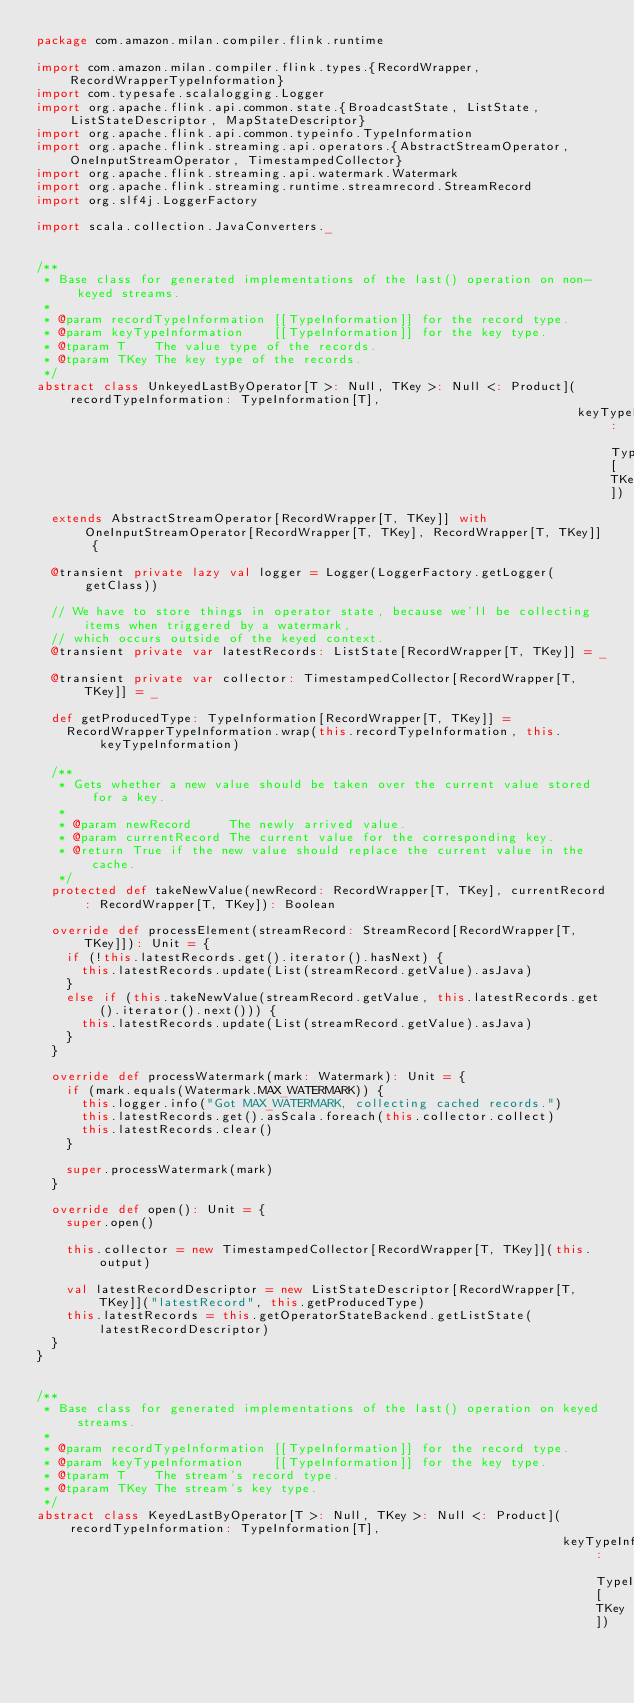<code> <loc_0><loc_0><loc_500><loc_500><_Scala_>package com.amazon.milan.compiler.flink.runtime

import com.amazon.milan.compiler.flink.types.{RecordWrapper, RecordWrapperTypeInformation}
import com.typesafe.scalalogging.Logger
import org.apache.flink.api.common.state.{BroadcastState, ListState, ListStateDescriptor, MapStateDescriptor}
import org.apache.flink.api.common.typeinfo.TypeInformation
import org.apache.flink.streaming.api.operators.{AbstractStreamOperator, OneInputStreamOperator, TimestampedCollector}
import org.apache.flink.streaming.api.watermark.Watermark
import org.apache.flink.streaming.runtime.streamrecord.StreamRecord
import org.slf4j.LoggerFactory

import scala.collection.JavaConverters._


/**
 * Base class for generated implementations of the last() operation on non-keyed streams.
 *
 * @param recordTypeInformation [[TypeInformation]] for the record type.
 * @param keyTypeInformation    [[TypeInformation]] for the key type.
 * @tparam T    The value type of the records.
 * @tparam TKey The key type of the records.
 */
abstract class UnkeyedLastByOperator[T >: Null, TKey >: Null <: Product](recordTypeInformation: TypeInformation[T],
                                                                         keyTypeInformation: TypeInformation[TKey])
  extends AbstractStreamOperator[RecordWrapper[T, TKey]] with OneInputStreamOperator[RecordWrapper[T, TKey], RecordWrapper[T, TKey]] {

  @transient private lazy val logger = Logger(LoggerFactory.getLogger(getClass))

  // We have to store things in operator state, because we'll be collecting items when triggered by a watermark,
  // which occurs outside of the keyed context.
  @transient private var latestRecords: ListState[RecordWrapper[T, TKey]] = _

  @transient private var collector: TimestampedCollector[RecordWrapper[T, TKey]] = _

  def getProducedType: TypeInformation[RecordWrapper[T, TKey]] =
    RecordWrapperTypeInformation.wrap(this.recordTypeInformation, this.keyTypeInformation)

  /**
   * Gets whether a new value should be taken over the current value stored for a key.
   *
   * @param newRecord     The newly arrived value.
   * @param currentRecord The current value for the corresponding key.
   * @return True if the new value should replace the current value in the cache.
   */
  protected def takeNewValue(newRecord: RecordWrapper[T, TKey], currentRecord: RecordWrapper[T, TKey]): Boolean

  override def processElement(streamRecord: StreamRecord[RecordWrapper[T, TKey]]): Unit = {
    if (!this.latestRecords.get().iterator().hasNext) {
      this.latestRecords.update(List(streamRecord.getValue).asJava)
    }
    else if (this.takeNewValue(streamRecord.getValue, this.latestRecords.get().iterator().next())) {
      this.latestRecords.update(List(streamRecord.getValue).asJava)
    }
  }

  override def processWatermark(mark: Watermark): Unit = {
    if (mark.equals(Watermark.MAX_WATERMARK)) {
      this.logger.info("Got MAX_WATERMARK, collecting cached records.")
      this.latestRecords.get().asScala.foreach(this.collector.collect)
      this.latestRecords.clear()
    }

    super.processWatermark(mark)
  }

  override def open(): Unit = {
    super.open()

    this.collector = new TimestampedCollector[RecordWrapper[T, TKey]](this.output)

    val latestRecordDescriptor = new ListStateDescriptor[RecordWrapper[T, TKey]]("latestRecord", this.getProducedType)
    this.latestRecords = this.getOperatorStateBackend.getListState(latestRecordDescriptor)
  }
}


/**
 * Base class for generated implementations of the last() operation on keyed streams.
 *
 * @param recordTypeInformation [[TypeInformation]] for the record type.
 * @param keyTypeInformation    [[TypeInformation]] for the key type.
 * @tparam T    The stream's record type.
 * @tparam TKey The stream's key type.
 */
abstract class KeyedLastByOperator[T >: Null, TKey >: Null <: Product](recordTypeInformation: TypeInformation[T],
                                                                       keyTypeInformation: TypeInformation[TKey])</code> 